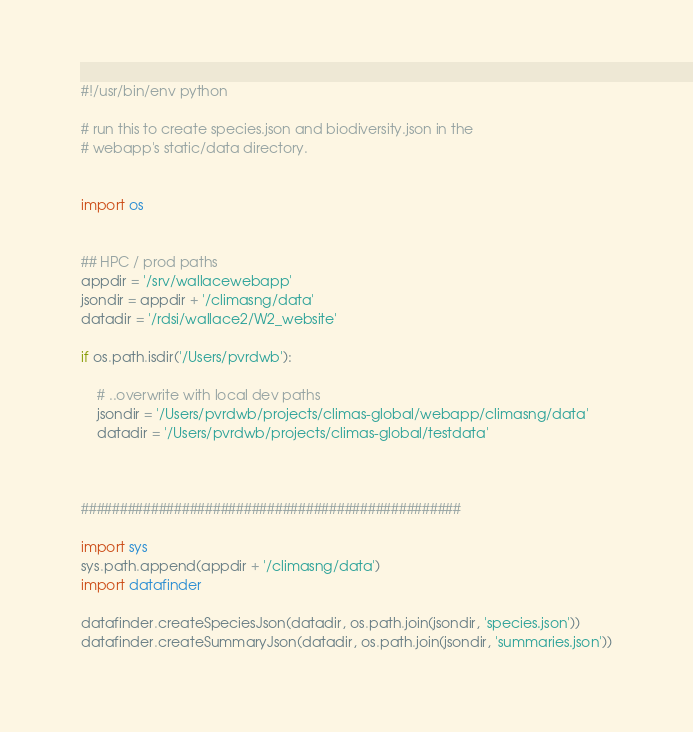Convert code to text. <code><loc_0><loc_0><loc_500><loc_500><_Python_>#!/usr/bin/env python

# run this to create species.json and biodiversity.json in the
# webapp's static/data directory.


import os


## HPC / prod paths
appdir = '/srv/wallacewebapp'
jsondir = appdir + '/climasng/data'
datadir = '/rdsi/wallace2/W2_website'

if os.path.isdir('/Users/pvrdwb'):

	# ..overwrite with local dev paths
	jsondir = '/Users/pvrdwb/projects/climas-global/webapp/climasng/data'
	datadir = '/Users/pvrdwb/projects/climas-global/testdata'



#################################################

import sys
sys.path.append(appdir + '/climasng/data')
import datafinder

datafinder.createSpeciesJson(datadir, os.path.join(jsondir, 'species.json'))
datafinder.createSummaryJson(datadir, os.path.join(jsondir, 'summaries.json'))</code> 